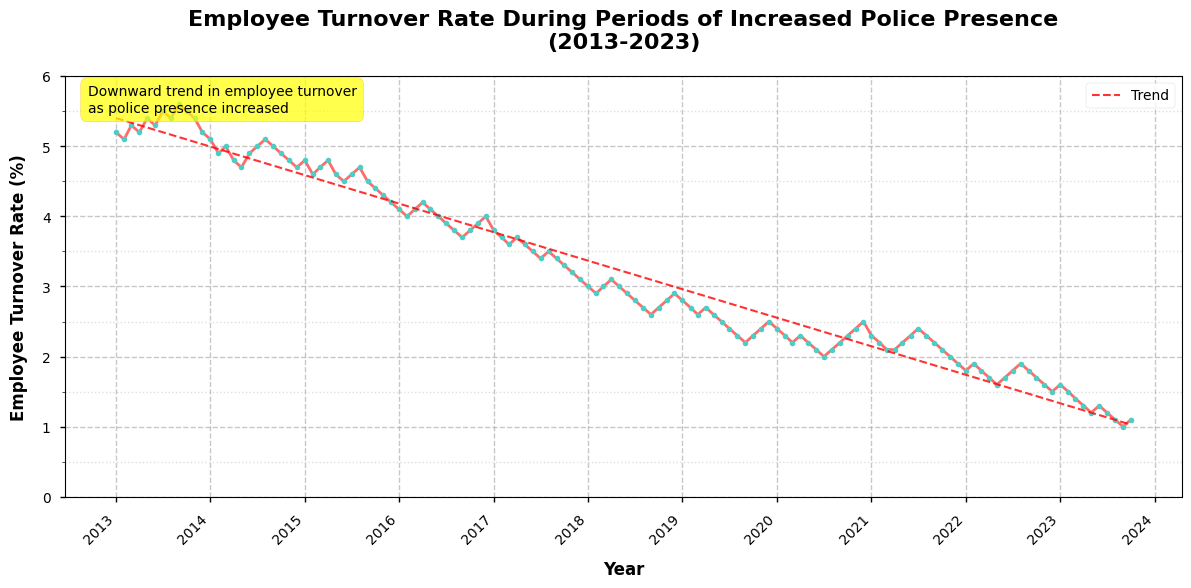What is the title of the figure? The title of the figure is located at the top of the plot and it describes the main topic being visualized. It reads "Employee Turnover Rate During Periods of Increased Police Presence (2013-2023)."
Answer: Employee Turnover Rate During Periods of Increased Police Presence (2013-2023) What is the y-axis label? The y-axis label explains what is being measured along the vertical axis. It reads "Employee Turnover Rate (%)".
Answer: Employee Turnover Rate (%) What trend is shown by the red dashed line? The red dashed line is a trend line added to the plot. It shows a general downward trend in employee turnover over the period from 2013 to 2023.
Answer: Downward trend Which year had the lowest employee turnover rate? By looking at the plot, the lowest point in the time series occurs in 2023. The employee turnover rate is at its minimum in September 2023 where the rate is 1.0%.
Answer: 2023 How did the employee turnover rate change from 2013 to 2023? To determine the change, compare the value at the start and end of the period displayed. The employee turnover rate started at around 5.2% at the beginning of 2013 and decreased to around 1.0% by the end of 2023.
Answer: Decreased What was the employee turnover rate in January 2020? Locate the data point for January 2020 along the x-axis, then observe its corresponding value on the y-axis. The employee turnover rate in January 2020 was 2.4%.
Answer: 2.4% During which year did the employee turnover rate first drop below 3.0%? Trace the time series and identify the first point where the employee turnover rate dips below 3.0%. This first occurs in 2018.
Answer: 2018 How does the turnover rate in January 2016 compare to that in January 2021? Identify the values for January 2016 and January 2021 on the plot and compare them. The rate was 4.1% in January 2016 and 2.3% in January 2021, showing a decrease.
Answer: Decreased On average, how much did the employee turnover rate decline per year over the period from 2013 to 2023? To answer this, calculate the total reduction in turnover rate from 2013 to 2023 (5.2% - 1.0% = 4.2%) and then divide by the number of years (2023 - 2013 = 10 years). So, 4.2% / 10 = 0.42% per year.
Answer: 0.42% per year What pattern does the annotation on the plot describe? The annotation text on the plot outlines the general observation or insight related to the data. It mentions a "Downward trend in employee turnover as police presence increased". This confirms the visual pattern noted in the trend line.
Answer: Downward trend in employee turnover as police presence increased 